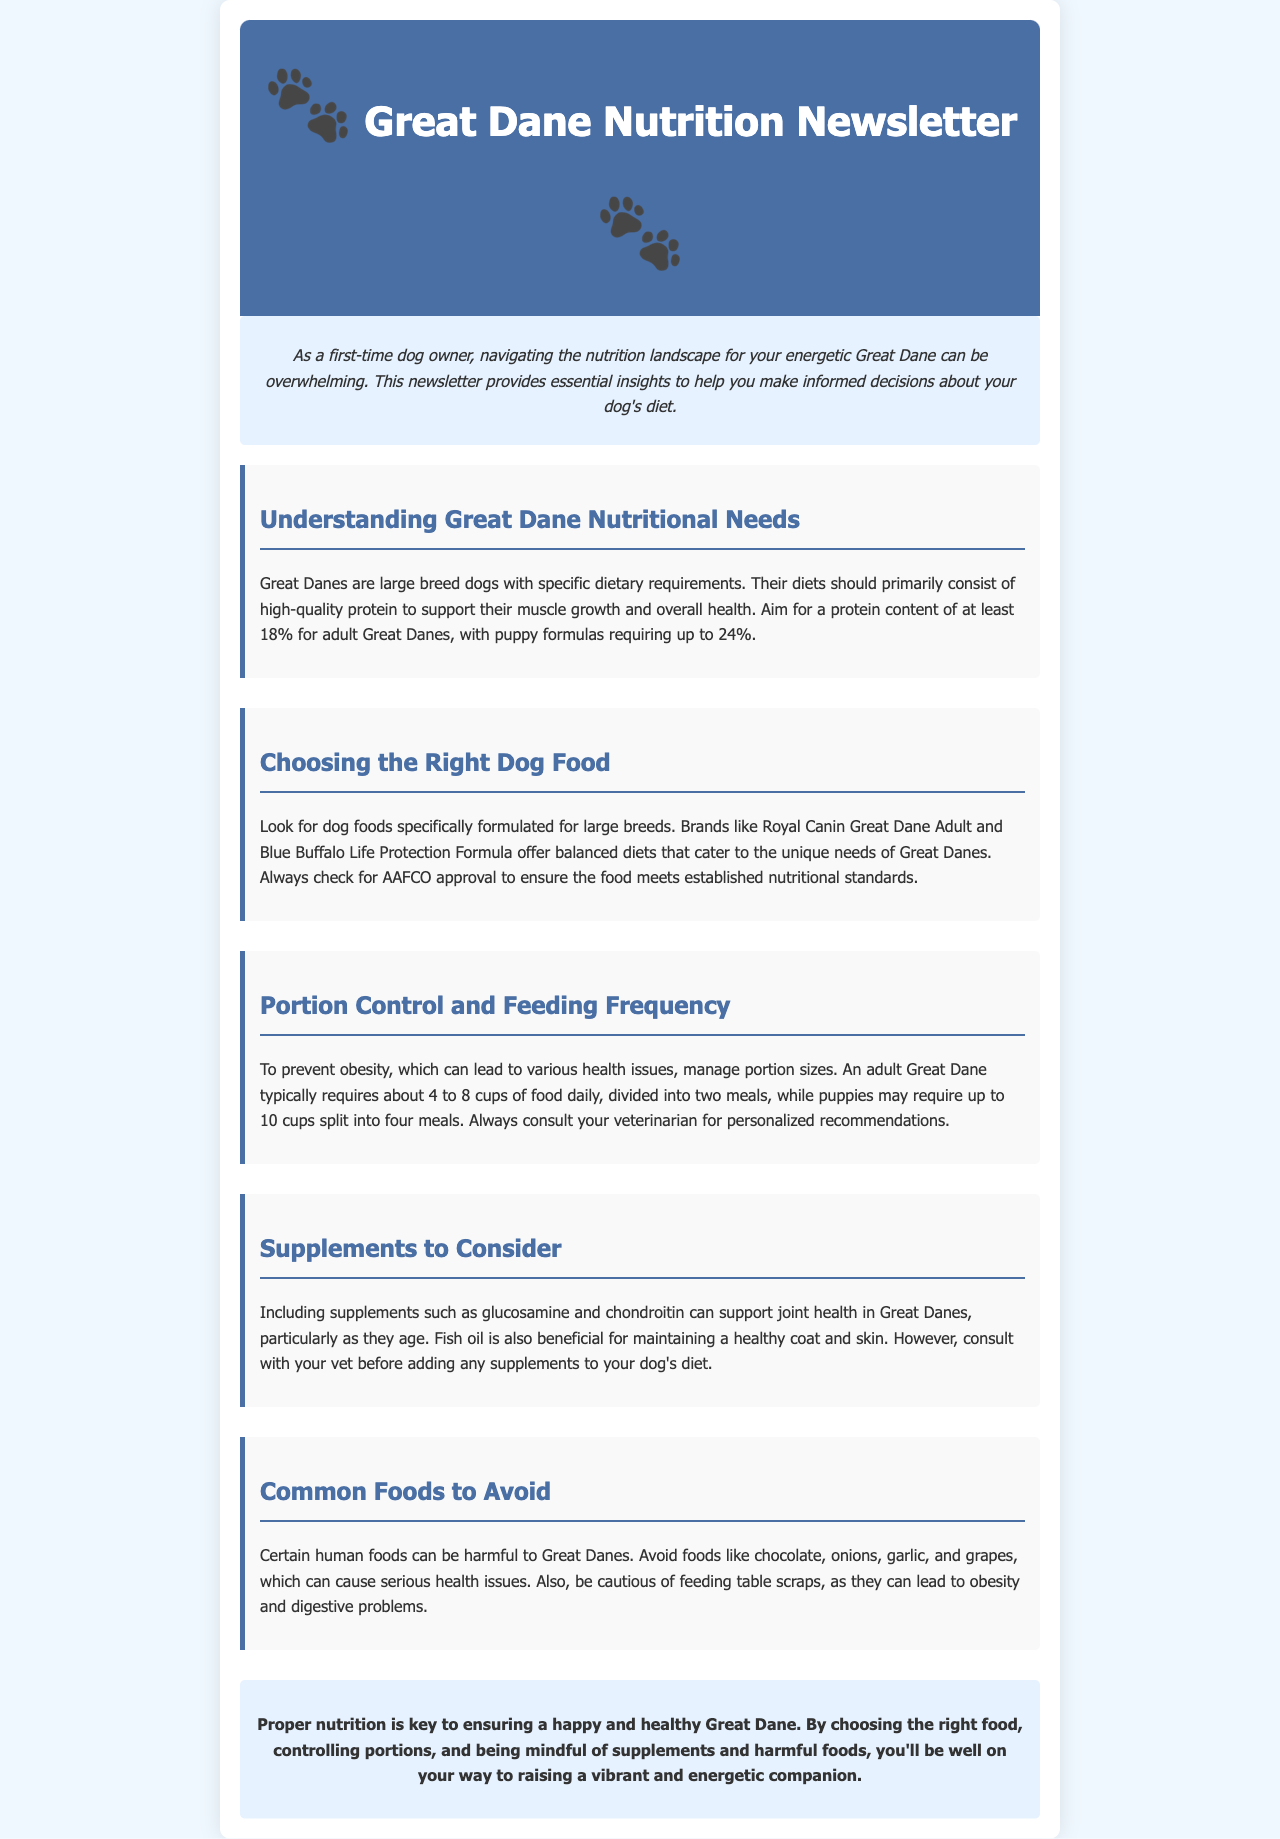What is the minimum protein content for adult Great Danes? The document specifies that adult Great Danes require a protein content of at least 18%.
Answer: 18% What type of dog food should Great Danes be fed? The newsletter recommends dog foods specifically formulated for large breeds.
Answer: Large breed How many cups of food does an adult Great Dane typically require daily? The document states that an adult Great Dane typically requires about 4 to 8 cups of food daily.
Answer: 4 to 8 cups Which supplements are beneficial for joint health in Great Danes? The document mentions glucosamine and chondroitin as beneficial supplements for joint health.
Answer: Glucosamine and chondroitin What foods should be avoided to prevent health issues in Great Danes? The newsletter lists chocolate, onions, garlic, and grapes as harmful foods for Great Danes.
Answer: Chocolate, onions, garlic, grapes How often should meals be divided for puppies? The document indicates that puppies may require up to 10 cups of food divided into four meals.
Answer: Four meals What is a critical step in preventing obesity for Great Danes? The document highlights managing portion sizes as a critical step to prevent obesity.
Answer: Managing portion sizes Which dog food brands are mentioned for Great Danes? The newsletter mentions Royal Canin Great Dane Adult and Blue Buffalo Life Protection Formula as recommended brands.
Answer: Royal Canin, Blue Buffalo What is the main focus of the newsletter? The document focuses on providing insights about nutrition and diet for Great Danes.
Answer: Nutrition and diet 